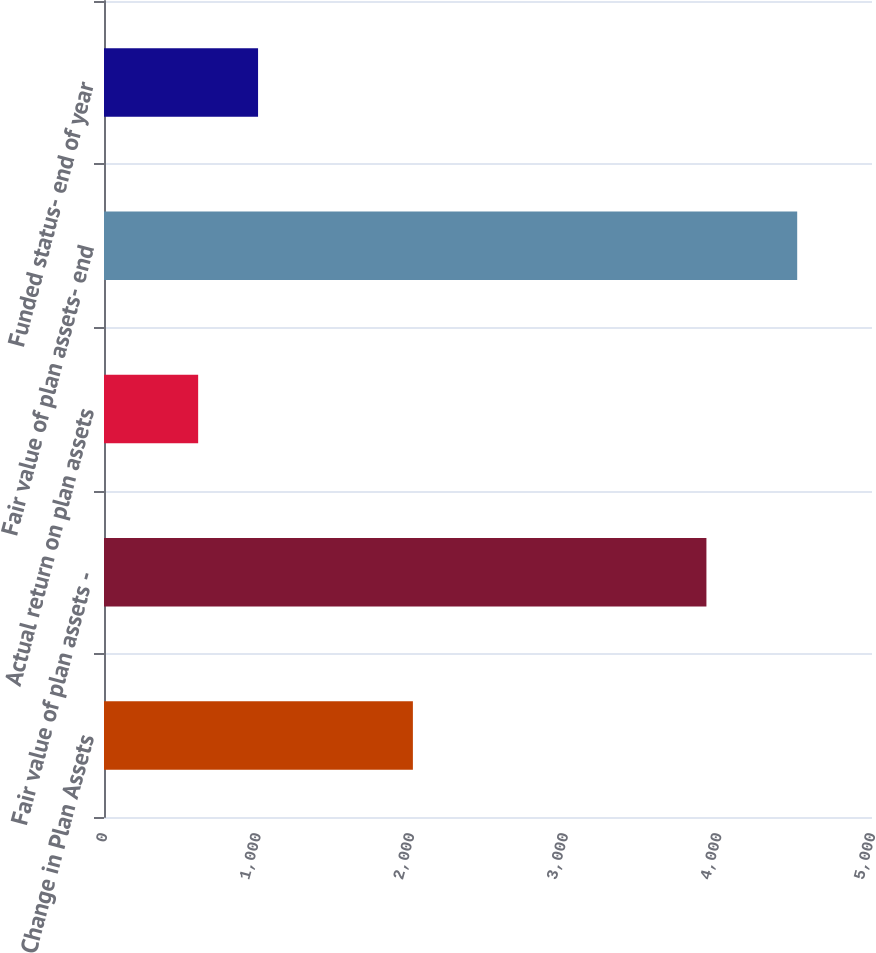<chart> <loc_0><loc_0><loc_500><loc_500><bar_chart><fcel>Change in Plan Assets<fcel>Fair value of plan assets -<fcel>Actual return on plan assets<fcel>Fair value of plan assets- end<fcel>Funded status- end of year<nl><fcel>2011<fcel>3922<fcel>613<fcel>4513<fcel>1003<nl></chart> 